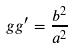<formula> <loc_0><loc_0><loc_500><loc_500>g g ^ { \prime } = \frac { b ^ { 2 } } { a ^ { 2 } }</formula> 